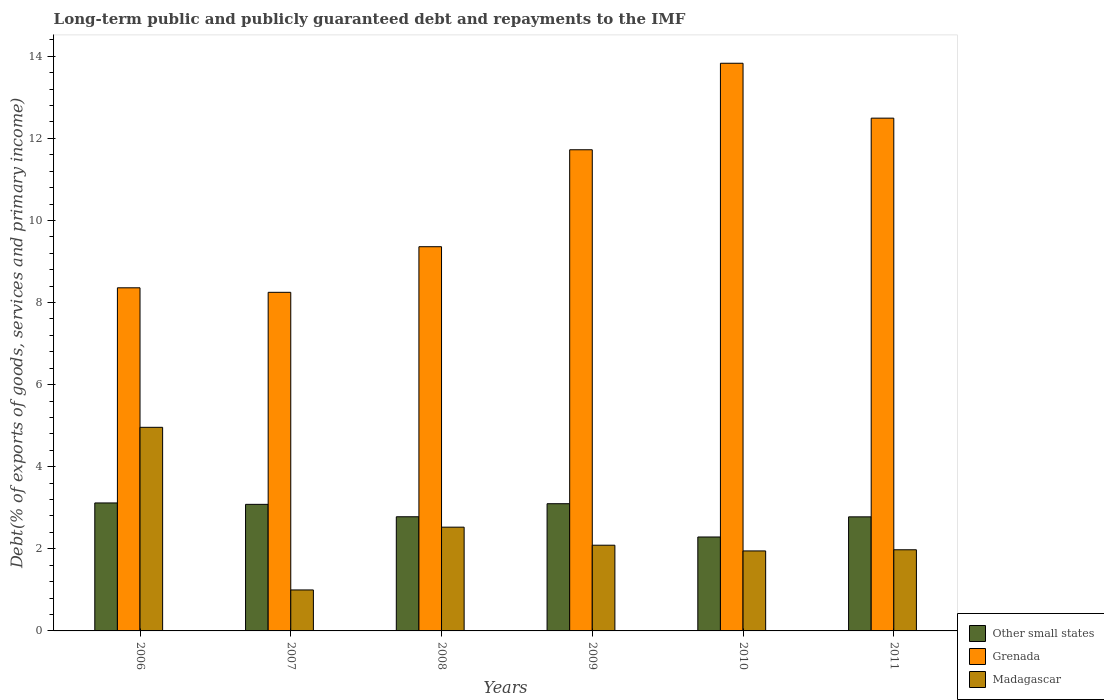How many groups of bars are there?
Ensure brevity in your answer.  6. How many bars are there on the 2nd tick from the left?
Your answer should be compact. 3. In how many cases, is the number of bars for a given year not equal to the number of legend labels?
Keep it short and to the point. 0. What is the debt and repayments in Madagascar in 2006?
Offer a very short reply. 4.96. Across all years, what is the maximum debt and repayments in Grenada?
Ensure brevity in your answer.  13.83. Across all years, what is the minimum debt and repayments in Grenada?
Offer a very short reply. 8.25. What is the total debt and repayments in Other small states in the graph?
Your answer should be very brief. 17.15. What is the difference between the debt and repayments in Grenada in 2008 and that in 2009?
Your response must be concise. -2.36. What is the difference between the debt and repayments in Madagascar in 2008 and the debt and repayments in Other small states in 2010?
Your answer should be very brief. 0.24. What is the average debt and repayments in Other small states per year?
Offer a very short reply. 2.86. In the year 2010, what is the difference between the debt and repayments in Other small states and debt and repayments in Grenada?
Make the answer very short. -11.54. In how many years, is the debt and repayments in Grenada greater than 11.6 %?
Offer a very short reply. 3. What is the ratio of the debt and repayments in Grenada in 2008 to that in 2011?
Offer a very short reply. 0.75. Is the difference between the debt and repayments in Other small states in 2010 and 2011 greater than the difference between the debt and repayments in Grenada in 2010 and 2011?
Ensure brevity in your answer.  No. What is the difference between the highest and the second highest debt and repayments in Grenada?
Offer a very short reply. 1.34. What is the difference between the highest and the lowest debt and repayments in Madagascar?
Keep it short and to the point. 3.96. In how many years, is the debt and repayments in Grenada greater than the average debt and repayments in Grenada taken over all years?
Your answer should be very brief. 3. What does the 1st bar from the left in 2006 represents?
Your answer should be compact. Other small states. What does the 3rd bar from the right in 2011 represents?
Make the answer very short. Other small states. How many bars are there?
Provide a succinct answer. 18. Are all the bars in the graph horizontal?
Give a very brief answer. No. How many years are there in the graph?
Keep it short and to the point. 6. What is the difference between two consecutive major ticks on the Y-axis?
Provide a short and direct response. 2. Are the values on the major ticks of Y-axis written in scientific E-notation?
Ensure brevity in your answer.  No. Does the graph contain grids?
Provide a short and direct response. No. What is the title of the graph?
Provide a succinct answer. Long-term public and publicly guaranteed debt and repayments to the IMF. What is the label or title of the Y-axis?
Give a very brief answer. Debt(% of exports of goods, services and primary income). What is the Debt(% of exports of goods, services and primary income) in Other small states in 2006?
Offer a very short reply. 3.12. What is the Debt(% of exports of goods, services and primary income) in Grenada in 2006?
Your answer should be compact. 8.36. What is the Debt(% of exports of goods, services and primary income) of Madagascar in 2006?
Ensure brevity in your answer.  4.96. What is the Debt(% of exports of goods, services and primary income) of Other small states in 2007?
Keep it short and to the point. 3.08. What is the Debt(% of exports of goods, services and primary income) in Grenada in 2007?
Ensure brevity in your answer.  8.25. What is the Debt(% of exports of goods, services and primary income) of Madagascar in 2007?
Make the answer very short. 1. What is the Debt(% of exports of goods, services and primary income) of Other small states in 2008?
Keep it short and to the point. 2.78. What is the Debt(% of exports of goods, services and primary income) of Grenada in 2008?
Provide a short and direct response. 9.36. What is the Debt(% of exports of goods, services and primary income) of Madagascar in 2008?
Offer a terse response. 2.53. What is the Debt(% of exports of goods, services and primary income) of Other small states in 2009?
Provide a short and direct response. 3.1. What is the Debt(% of exports of goods, services and primary income) of Grenada in 2009?
Offer a terse response. 11.72. What is the Debt(% of exports of goods, services and primary income) of Madagascar in 2009?
Your answer should be very brief. 2.09. What is the Debt(% of exports of goods, services and primary income) in Other small states in 2010?
Ensure brevity in your answer.  2.29. What is the Debt(% of exports of goods, services and primary income) in Grenada in 2010?
Offer a terse response. 13.83. What is the Debt(% of exports of goods, services and primary income) of Madagascar in 2010?
Keep it short and to the point. 1.95. What is the Debt(% of exports of goods, services and primary income) of Other small states in 2011?
Your answer should be very brief. 2.78. What is the Debt(% of exports of goods, services and primary income) of Grenada in 2011?
Provide a short and direct response. 12.49. What is the Debt(% of exports of goods, services and primary income) of Madagascar in 2011?
Offer a terse response. 1.98. Across all years, what is the maximum Debt(% of exports of goods, services and primary income) in Other small states?
Give a very brief answer. 3.12. Across all years, what is the maximum Debt(% of exports of goods, services and primary income) in Grenada?
Keep it short and to the point. 13.83. Across all years, what is the maximum Debt(% of exports of goods, services and primary income) in Madagascar?
Your response must be concise. 4.96. Across all years, what is the minimum Debt(% of exports of goods, services and primary income) of Other small states?
Your answer should be compact. 2.29. Across all years, what is the minimum Debt(% of exports of goods, services and primary income) in Grenada?
Give a very brief answer. 8.25. Across all years, what is the minimum Debt(% of exports of goods, services and primary income) in Madagascar?
Provide a short and direct response. 1. What is the total Debt(% of exports of goods, services and primary income) in Other small states in the graph?
Offer a very short reply. 17.15. What is the total Debt(% of exports of goods, services and primary income) in Grenada in the graph?
Keep it short and to the point. 64.01. What is the total Debt(% of exports of goods, services and primary income) in Madagascar in the graph?
Your response must be concise. 14.5. What is the difference between the Debt(% of exports of goods, services and primary income) of Other small states in 2006 and that in 2007?
Your response must be concise. 0.03. What is the difference between the Debt(% of exports of goods, services and primary income) in Grenada in 2006 and that in 2007?
Offer a terse response. 0.11. What is the difference between the Debt(% of exports of goods, services and primary income) in Madagascar in 2006 and that in 2007?
Ensure brevity in your answer.  3.96. What is the difference between the Debt(% of exports of goods, services and primary income) in Other small states in 2006 and that in 2008?
Provide a short and direct response. 0.34. What is the difference between the Debt(% of exports of goods, services and primary income) in Grenada in 2006 and that in 2008?
Make the answer very short. -1. What is the difference between the Debt(% of exports of goods, services and primary income) in Madagascar in 2006 and that in 2008?
Provide a short and direct response. 2.43. What is the difference between the Debt(% of exports of goods, services and primary income) of Other small states in 2006 and that in 2009?
Keep it short and to the point. 0.02. What is the difference between the Debt(% of exports of goods, services and primary income) of Grenada in 2006 and that in 2009?
Your answer should be very brief. -3.36. What is the difference between the Debt(% of exports of goods, services and primary income) of Madagascar in 2006 and that in 2009?
Your answer should be very brief. 2.87. What is the difference between the Debt(% of exports of goods, services and primary income) in Other small states in 2006 and that in 2010?
Offer a very short reply. 0.83. What is the difference between the Debt(% of exports of goods, services and primary income) of Grenada in 2006 and that in 2010?
Your answer should be very brief. -5.47. What is the difference between the Debt(% of exports of goods, services and primary income) in Madagascar in 2006 and that in 2010?
Offer a very short reply. 3.01. What is the difference between the Debt(% of exports of goods, services and primary income) in Other small states in 2006 and that in 2011?
Your answer should be compact. 0.34. What is the difference between the Debt(% of exports of goods, services and primary income) in Grenada in 2006 and that in 2011?
Keep it short and to the point. -4.13. What is the difference between the Debt(% of exports of goods, services and primary income) in Madagascar in 2006 and that in 2011?
Provide a succinct answer. 2.98. What is the difference between the Debt(% of exports of goods, services and primary income) of Other small states in 2007 and that in 2008?
Offer a very short reply. 0.3. What is the difference between the Debt(% of exports of goods, services and primary income) of Grenada in 2007 and that in 2008?
Offer a terse response. -1.11. What is the difference between the Debt(% of exports of goods, services and primary income) of Madagascar in 2007 and that in 2008?
Keep it short and to the point. -1.53. What is the difference between the Debt(% of exports of goods, services and primary income) of Other small states in 2007 and that in 2009?
Your answer should be compact. -0.02. What is the difference between the Debt(% of exports of goods, services and primary income) in Grenada in 2007 and that in 2009?
Give a very brief answer. -3.47. What is the difference between the Debt(% of exports of goods, services and primary income) in Madagascar in 2007 and that in 2009?
Offer a very short reply. -1.09. What is the difference between the Debt(% of exports of goods, services and primary income) of Other small states in 2007 and that in 2010?
Your answer should be very brief. 0.79. What is the difference between the Debt(% of exports of goods, services and primary income) in Grenada in 2007 and that in 2010?
Your response must be concise. -5.58. What is the difference between the Debt(% of exports of goods, services and primary income) of Madagascar in 2007 and that in 2010?
Your answer should be compact. -0.95. What is the difference between the Debt(% of exports of goods, services and primary income) of Other small states in 2007 and that in 2011?
Ensure brevity in your answer.  0.3. What is the difference between the Debt(% of exports of goods, services and primary income) in Grenada in 2007 and that in 2011?
Ensure brevity in your answer.  -4.24. What is the difference between the Debt(% of exports of goods, services and primary income) of Madagascar in 2007 and that in 2011?
Offer a terse response. -0.98. What is the difference between the Debt(% of exports of goods, services and primary income) in Other small states in 2008 and that in 2009?
Ensure brevity in your answer.  -0.32. What is the difference between the Debt(% of exports of goods, services and primary income) in Grenada in 2008 and that in 2009?
Your answer should be compact. -2.36. What is the difference between the Debt(% of exports of goods, services and primary income) in Madagascar in 2008 and that in 2009?
Give a very brief answer. 0.44. What is the difference between the Debt(% of exports of goods, services and primary income) of Other small states in 2008 and that in 2010?
Offer a very short reply. 0.49. What is the difference between the Debt(% of exports of goods, services and primary income) in Grenada in 2008 and that in 2010?
Your response must be concise. -4.47. What is the difference between the Debt(% of exports of goods, services and primary income) in Madagascar in 2008 and that in 2010?
Keep it short and to the point. 0.58. What is the difference between the Debt(% of exports of goods, services and primary income) of Other small states in 2008 and that in 2011?
Your answer should be very brief. 0. What is the difference between the Debt(% of exports of goods, services and primary income) in Grenada in 2008 and that in 2011?
Your answer should be very brief. -3.13. What is the difference between the Debt(% of exports of goods, services and primary income) of Madagascar in 2008 and that in 2011?
Offer a very short reply. 0.55. What is the difference between the Debt(% of exports of goods, services and primary income) in Other small states in 2009 and that in 2010?
Keep it short and to the point. 0.81. What is the difference between the Debt(% of exports of goods, services and primary income) of Grenada in 2009 and that in 2010?
Provide a succinct answer. -2.11. What is the difference between the Debt(% of exports of goods, services and primary income) of Madagascar in 2009 and that in 2010?
Give a very brief answer. 0.14. What is the difference between the Debt(% of exports of goods, services and primary income) of Other small states in 2009 and that in 2011?
Offer a terse response. 0.32. What is the difference between the Debt(% of exports of goods, services and primary income) of Grenada in 2009 and that in 2011?
Provide a short and direct response. -0.77. What is the difference between the Debt(% of exports of goods, services and primary income) of Madagascar in 2009 and that in 2011?
Give a very brief answer. 0.11. What is the difference between the Debt(% of exports of goods, services and primary income) in Other small states in 2010 and that in 2011?
Offer a very short reply. -0.49. What is the difference between the Debt(% of exports of goods, services and primary income) in Grenada in 2010 and that in 2011?
Provide a short and direct response. 1.34. What is the difference between the Debt(% of exports of goods, services and primary income) in Madagascar in 2010 and that in 2011?
Ensure brevity in your answer.  -0.03. What is the difference between the Debt(% of exports of goods, services and primary income) in Other small states in 2006 and the Debt(% of exports of goods, services and primary income) in Grenada in 2007?
Offer a very short reply. -5.13. What is the difference between the Debt(% of exports of goods, services and primary income) in Other small states in 2006 and the Debt(% of exports of goods, services and primary income) in Madagascar in 2007?
Provide a short and direct response. 2.12. What is the difference between the Debt(% of exports of goods, services and primary income) of Grenada in 2006 and the Debt(% of exports of goods, services and primary income) of Madagascar in 2007?
Give a very brief answer. 7.36. What is the difference between the Debt(% of exports of goods, services and primary income) of Other small states in 2006 and the Debt(% of exports of goods, services and primary income) of Grenada in 2008?
Make the answer very short. -6.24. What is the difference between the Debt(% of exports of goods, services and primary income) of Other small states in 2006 and the Debt(% of exports of goods, services and primary income) of Madagascar in 2008?
Offer a terse response. 0.59. What is the difference between the Debt(% of exports of goods, services and primary income) in Grenada in 2006 and the Debt(% of exports of goods, services and primary income) in Madagascar in 2008?
Offer a very short reply. 5.83. What is the difference between the Debt(% of exports of goods, services and primary income) in Other small states in 2006 and the Debt(% of exports of goods, services and primary income) in Grenada in 2009?
Provide a succinct answer. -8.6. What is the difference between the Debt(% of exports of goods, services and primary income) of Other small states in 2006 and the Debt(% of exports of goods, services and primary income) of Madagascar in 2009?
Give a very brief answer. 1.03. What is the difference between the Debt(% of exports of goods, services and primary income) of Grenada in 2006 and the Debt(% of exports of goods, services and primary income) of Madagascar in 2009?
Your answer should be very brief. 6.27. What is the difference between the Debt(% of exports of goods, services and primary income) of Other small states in 2006 and the Debt(% of exports of goods, services and primary income) of Grenada in 2010?
Give a very brief answer. -10.71. What is the difference between the Debt(% of exports of goods, services and primary income) in Other small states in 2006 and the Debt(% of exports of goods, services and primary income) in Madagascar in 2010?
Your answer should be very brief. 1.17. What is the difference between the Debt(% of exports of goods, services and primary income) of Grenada in 2006 and the Debt(% of exports of goods, services and primary income) of Madagascar in 2010?
Keep it short and to the point. 6.41. What is the difference between the Debt(% of exports of goods, services and primary income) of Other small states in 2006 and the Debt(% of exports of goods, services and primary income) of Grenada in 2011?
Your answer should be compact. -9.37. What is the difference between the Debt(% of exports of goods, services and primary income) of Other small states in 2006 and the Debt(% of exports of goods, services and primary income) of Madagascar in 2011?
Your answer should be compact. 1.14. What is the difference between the Debt(% of exports of goods, services and primary income) in Grenada in 2006 and the Debt(% of exports of goods, services and primary income) in Madagascar in 2011?
Ensure brevity in your answer.  6.38. What is the difference between the Debt(% of exports of goods, services and primary income) in Other small states in 2007 and the Debt(% of exports of goods, services and primary income) in Grenada in 2008?
Offer a terse response. -6.28. What is the difference between the Debt(% of exports of goods, services and primary income) in Other small states in 2007 and the Debt(% of exports of goods, services and primary income) in Madagascar in 2008?
Keep it short and to the point. 0.56. What is the difference between the Debt(% of exports of goods, services and primary income) of Grenada in 2007 and the Debt(% of exports of goods, services and primary income) of Madagascar in 2008?
Give a very brief answer. 5.72. What is the difference between the Debt(% of exports of goods, services and primary income) in Other small states in 2007 and the Debt(% of exports of goods, services and primary income) in Grenada in 2009?
Offer a very short reply. -8.64. What is the difference between the Debt(% of exports of goods, services and primary income) of Other small states in 2007 and the Debt(% of exports of goods, services and primary income) of Madagascar in 2009?
Offer a very short reply. 1. What is the difference between the Debt(% of exports of goods, services and primary income) of Grenada in 2007 and the Debt(% of exports of goods, services and primary income) of Madagascar in 2009?
Offer a terse response. 6.16. What is the difference between the Debt(% of exports of goods, services and primary income) of Other small states in 2007 and the Debt(% of exports of goods, services and primary income) of Grenada in 2010?
Keep it short and to the point. -10.75. What is the difference between the Debt(% of exports of goods, services and primary income) in Other small states in 2007 and the Debt(% of exports of goods, services and primary income) in Madagascar in 2010?
Your response must be concise. 1.13. What is the difference between the Debt(% of exports of goods, services and primary income) of Other small states in 2007 and the Debt(% of exports of goods, services and primary income) of Grenada in 2011?
Your response must be concise. -9.41. What is the difference between the Debt(% of exports of goods, services and primary income) in Other small states in 2007 and the Debt(% of exports of goods, services and primary income) in Madagascar in 2011?
Ensure brevity in your answer.  1.11. What is the difference between the Debt(% of exports of goods, services and primary income) of Grenada in 2007 and the Debt(% of exports of goods, services and primary income) of Madagascar in 2011?
Give a very brief answer. 6.27. What is the difference between the Debt(% of exports of goods, services and primary income) in Other small states in 2008 and the Debt(% of exports of goods, services and primary income) in Grenada in 2009?
Provide a succinct answer. -8.94. What is the difference between the Debt(% of exports of goods, services and primary income) in Other small states in 2008 and the Debt(% of exports of goods, services and primary income) in Madagascar in 2009?
Your answer should be compact. 0.69. What is the difference between the Debt(% of exports of goods, services and primary income) in Grenada in 2008 and the Debt(% of exports of goods, services and primary income) in Madagascar in 2009?
Keep it short and to the point. 7.27. What is the difference between the Debt(% of exports of goods, services and primary income) of Other small states in 2008 and the Debt(% of exports of goods, services and primary income) of Grenada in 2010?
Keep it short and to the point. -11.05. What is the difference between the Debt(% of exports of goods, services and primary income) in Other small states in 2008 and the Debt(% of exports of goods, services and primary income) in Madagascar in 2010?
Provide a succinct answer. 0.83. What is the difference between the Debt(% of exports of goods, services and primary income) of Grenada in 2008 and the Debt(% of exports of goods, services and primary income) of Madagascar in 2010?
Your answer should be very brief. 7.41. What is the difference between the Debt(% of exports of goods, services and primary income) in Other small states in 2008 and the Debt(% of exports of goods, services and primary income) in Grenada in 2011?
Keep it short and to the point. -9.71. What is the difference between the Debt(% of exports of goods, services and primary income) in Other small states in 2008 and the Debt(% of exports of goods, services and primary income) in Madagascar in 2011?
Your answer should be compact. 0.8. What is the difference between the Debt(% of exports of goods, services and primary income) of Grenada in 2008 and the Debt(% of exports of goods, services and primary income) of Madagascar in 2011?
Your answer should be very brief. 7.38. What is the difference between the Debt(% of exports of goods, services and primary income) of Other small states in 2009 and the Debt(% of exports of goods, services and primary income) of Grenada in 2010?
Provide a short and direct response. -10.73. What is the difference between the Debt(% of exports of goods, services and primary income) of Other small states in 2009 and the Debt(% of exports of goods, services and primary income) of Madagascar in 2010?
Ensure brevity in your answer.  1.15. What is the difference between the Debt(% of exports of goods, services and primary income) in Grenada in 2009 and the Debt(% of exports of goods, services and primary income) in Madagascar in 2010?
Keep it short and to the point. 9.77. What is the difference between the Debt(% of exports of goods, services and primary income) of Other small states in 2009 and the Debt(% of exports of goods, services and primary income) of Grenada in 2011?
Your answer should be compact. -9.39. What is the difference between the Debt(% of exports of goods, services and primary income) in Other small states in 2009 and the Debt(% of exports of goods, services and primary income) in Madagascar in 2011?
Your answer should be compact. 1.12. What is the difference between the Debt(% of exports of goods, services and primary income) of Grenada in 2009 and the Debt(% of exports of goods, services and primary income) of Madagascar in 2011?
Your response must be concise. 9.74. What is the difference between the Debt(% of exports of goods, services and primary income) in Other small states in 2010 and the Debt(% of exports of goods, services and primary income) in Grenada in 2011?
Provide a short and direct response. -10.2. What is the difference between the Debt(% of exports of goods, services and primary income) of Other small states in 2010 and the Debt(% of exports of goods, services and primary income) of Madagascar in 2011?
Offer a very short reply. 0.31. What is the difference between the Debt(% of exports of goods, services and primary income) of Grenada in 2010 and the Debt(% of exports of goods, services and primary income) of Madagascar in 2011?
Keep it short and to the point. 11.85. What is the average Debt(% of exports of goods, services and primary income) in Other small states per year?
Provide a succinct answer. 2.86. What is the average Debt(% of exports of goods, services and primary income) of Grenada per year?
Your response must be concise. 10.67. What is the average Debt(% of exports of goods, services and primary income) in Madagascar per year?
Provide a short and direct response. 2.42. In the year 2006, what is the difference between the Debt(% of exports of goods, services and primary income) of Other small states and Debt(% of exports of goods, services and primary income) of Grenada?
Your response must be concise. -5.24. In the year 2006, what is the difference between the Debt(% of exports of goods, services and primary income) in Other small states and Debt(% of exports of goods, services and primary income) in Madagascar?
Keep it short and to the point. -1.84. In the year 2006, what is the difference between the Debt(% of exports of goods, services and primary income) of Grenada and Debt(% of exports of goods, services and primary income) of Madagascar?
Offer a very short reply. 3.4. In the year 2007, what is the difference between the Debt(% of exports of goods, services and primary income) in Other small states and Debt(% of exports of goods, services and primary income) in Grenada?
Provide a succinct answer. -5.17. In the year 2007, what is the difference between the Debt(% of exports of goods, services and primary income) in Other small states and Debt(% of exports of goods, services and primary income) in Madagascar?
Offer a terse response. 2.09. In the year 2007, what is the difference between the Debt(% of exports of goods, services and primary income) of Grenada and Debt(% of exports of goods, services and primary income) of Madagascar?
Provide a short and direct response. 7.25. In the year 2008, what is the difference between the Debt(% of exports of goods, services and primary income) in Other small states and Debt(% of exports of goods, services and primary income) in Grenada?
Provide a short and direct response. -6.58. In the year 2008, what is the difference between the Debt(% of exports of goods, services and primary income) of Other small states and Debt(% of exports of goods, services and primary income) of Madagascar?
Give a very brief answer. 0.25. In the year 2008, what is the difference between the Debt(% of exports of goods, services and primary income) in Grenada and Debt(% of exports of goods, services and primary income) in Madagascar?
Your answer should be compact. 6.83. In the year 2009, what is the difference between the Debt(% of exports of goods, services and primary income) of Other small states and Debt(% of exports of goods, services and primary income) of Grenada?
Offer a very short reply. -8.62. In the year 2009, what is the difference between the Debt(% of exports of goods, services and primary income) in Other small states and Debt(% of exports of goods, services and primary income) in Madagascar?
Ensure brevity in your answer.  1.01. In the year 2009, what is the difference between the Debt(% of exports of goods, services and primary income) in Grenada and Debt(% of exports of goods, services and primary income) in Madagascar?
Your answer should be very brief. 9.63. In the year 2010, what is the difference between the Debt(% of exports of goods, services and primary income) of Other small states and Debt(% of exports of goods, services and primary income) of Grenada?
Your answer should be compact. -11.54. In the year 2010, what is the difference between the Debt(% of exports of goods, services and primary income) of Other small states and Debt(% of exports of goods, services and primary income) of Madagascar?
Provide a succinct answer. 0.34. In the year 2010, what is the difference between the Debt(% of exports of goods, services and primary income) of Grenada and Debt(% of exports of goods, services and primary income) of Madagascar?
Your response must be concise. 11.88. In the year 2011, what is the difference between the Debt(% of exports of goods, services and primary income) in Other small states and Debt(% of exports of goods, services and primary income) in Grenada?
Offer a very short reply. -9.71. In the year 2011, what is the difference between the Debt(% of exports of goods, services and primary income) in Other small states and Debt(% of exports of goods, services and primary income) in Madagascar?
Offer a very short reply. 0.8. In the year 2011, what is the difference between the Debt(% of exports of goods, services and primary income) in Grenada and Debt(% of exports of goods, services and primary income) in Madagascar?
Offer a terse response. 10.52. What is the ratio of the Debt(% of exports of goods, services and primary income) of Other small states in 2006 to that in 2007?
Offer a terse response. 1.01. What is the ratio of the Debt(% of exports of goods, services and primary income) of Grenada in 2006 to that in 2007?
Provide a short and direct response. 1.01. What is the ratio of the Debt(% of exports of goods, services and primary income) in Madagascar in 2006 to that in 2007?
Keep it short and to the point. 4.97. What is the ratio of the Debt(% of exports of goods, services and primary income) of Other small states in 2006 to that in 2008?
Your response must be concise. 1.12. What is the ratio of the Debt(% of exports of goods, services and primary income) of Grenada in 2006 to that in 2008?
Provide a succinct answer. 0.89. What is the ratio of the Debt(% of exports of goods, services and primary income) of Madagascar in 2006 to that in 2008?
Offer a very short reply. 1.96. What is the ratio of the Debt(% of exports of goods, services and primary income) of Other small states in 2006 to that in 2009?
Make the answer very short. 1.01. What is the ratio of the Debt(% of exports of goods, services and primary income) in Grenada in 2006 to that in 2009?
Provide a short and direct response. 0.71. What is the ratio of the Debt(% of exports of goods, services and primary income) in Madagascar in 2006 to that in 2009?
Provide a short and direct response. 2.38. What is the ratio of the Debt(% of exports of goods, services and primary income) in Other small states in 2006 to that in 2010?
Offer a very short reply. 1.36. What is the ratio of the Debt(% of exports of goods, services and primary income) in Grenada in 2006 to that in 2010?
Give a very brief answer. 0.6. What is the ratio of the Debt(% of exports of goods, services and primary income) of Madagascar in 2006 to that in 2010?
Your answer should be very brief. 2.55. What is the ratio of the Debt(% of exports of goods, services and primary income) in Other small states in 2006 to that in 2011?
Provide a succinct answer. 1.12. What is the ratio of the Debt(% of exports of goods, services and primary income) of Grenada in 2006 to that in 2011?
Your response must be concise. 0.67. What is the ratio of the Debt(% of exports of goods, services and primary income) of Madagascar in 2006 to that in 2011?
Offer a very short reply. 2.51. What is the ratio of the Debt(% of exports of goods, services and primary income) in Other small states in 2007 to that in 2008?
Your answer should be compact. 1.11. What is the ratio of the Debt(% of exports of goods, services and primary income) in Grenada in 2007 to that in 2008?
Ensure brevity in your answer.  0.88. What is the ratio of the Debt(% of exports of goods, services and primary income) in Madagascar in 2007 to that in 2008?
Offer a very short reply. 0.39. What is the ratio of the Debt(% of exports of goods, services and primary income) in Other small states in 2007 to that in 2009?
Ensure brevity in your answer.  0.99. What is the ratio of the Debt(% of exports of goods, services and primary income) of Grenada in 2007 to that in 2009?
Keep it short and to the point. 0.7. What is the ratio of the Debt(% of exports of goods, services and primary income) in Madagascar in 2007 to that in 2009?
Your answer should be compact. 0.48. What is the ratio of the Debt(% of exports of goods, services and primary income) of Other small states in 2007 to that in 2010?
Offer a terse response. 1.35. What is the ratio of the Debt(% of exports of goods, services and primary income) in Grenada in 2007 to that in 2010?
Offer a terse response. 0.6. What is the ratio of the Debt(% of exports of goods, services and primary income) of Madagascar in 2007 to that in 2010?
Provide a short and direct response. 0.51. What is the ratio of the Debt(% of exports of goods, services and primary income) of Other small states in 2007 to that in 2011?
Your response must be concise. 1.11. What is the ratio of the Debt(% of exports of goods, services and primary income) in Grenada in 2007 to that in 2011?
Make the answer very short. 0.66. What is the ratio of the Debt(% of exports of goods, services and primary income) of Madagascar in 2007 to that in 2011?
Ensure brevity in your answer.  0.51. What is the ratio of the Debt(% of exports of goods, services and primary income) in Other small states in 2008 to that in 2009?
Make the answer very short. 0.9. What is the ratio of the Debt(% of exports of goods, services and primary income) of Grenada in 2008 to that in 2009?
Offer a terse response. 0.8. What is the ratio of the Debt(% of exports of goods, services and primary income) of Madagascar in 2008 to that in 2009?
Ensure brevity in your answer.  1.21. What is the ratio of the Debt(% of exports of goods, services and primary income) in Other small states in 2008 to that in 2010?
Give a very brief answer. 1.22. What is the ratio of the Debt(% of exports of goods, services and primary income) in Grenada in 2008 to that in 2010?
Provide a succinct answer. 0.68. What is the ratio of the Debt(% of exports of goods, services and primary income) in Madagascar in 2008 to that in 2010?
Provide a short and direct response. 1.3. What is the ratio of the Debt(% of exports of goods, services and primary income) in Other small states in 2008 to that in 2011?
Offer a terse response. 1. What is the ratio of the Debt(% of exports of goods, services and primary income) in Grenada in 2008 to that in 2011?
Your response must be concise. 0.75. What is the ratio of the Debt(% of exports of goods, services and primary income) of Madagascar in 2008 to that in 2011?
Your answer should be very brief. 1.28. What is the ratio of the Debt(% of exports of goods, services and primary income) of Other small states in 2009 to that in 2010?
Keep it short and to the point. 1.35. What is the ratio of the Debt(% of exports of goods, services and primary income) of Grenada in 2009 to that in 2010?
Provide a short and direct response. 0.85. What is the ratio of the Debt(% of exports of goods, services and primary income) of Madagascar in 2009 to that in 2010?
Your answer should be compact. 1.07. What is the ratio of the Debt(% of exports of goods, services and primary income) in Other small states in 2009 to that in 2011?
Offer a terse response. 1.12. What is the ratio of the Debt(% of exports of goods, services and primary income) of Grenada in 2009 to that in 2011?
Your answer should be very brief. 0.94. What is the ratio of the Debt(% of exports of goods, services and primary income) of Madagascar in 2009 to that in 2011?
Offer a very short reply. 1.06. What is the ratio of the Debt(% of exports of goods, services and primary income) of Other small states in 2010 to that in 2011?
Give a very brief answer. 0.82. What is the ratio of the Debt(% of exports of goods, services and primary income) in Grenada in 2010 to that in 2011?
Offer a very short reply. 1.11. What is the ratio of the Debt(% of exports of goods, services and primary income) of Madagascar in 2010 to that in 2011?
Your answer should be compact. 0.99. What is the difference between the highest and the second highest Debt(% of exports of goods, services and primary income) in Other small states?
Your answer should be compact. 0.02. What is the difference between the highest and the second highest Debt(% of exports of goods, services and primary income) in Grenada?
Keep it short and to the point. 1.34. What is the difference between the highest and the second highest Debt(% of exports of goods, services and primary income) of Madagascar?
Your response must be concise. 2.43. What is the difference between the highest and the lowest Debt(% of exports of goods, services and primary income) of Other small states?
Your answer should be compact. 0.83. What is the difference between the highest and the lowest Debt(% of exports of goods, services and primary income) of Grenada?
Your answer should be very brief. 5.58. What is the difference between the highest and the lowest Debt(% of exports of goods, services and primary income) of Madagascar?
Your answer should be compact. 3.96. 